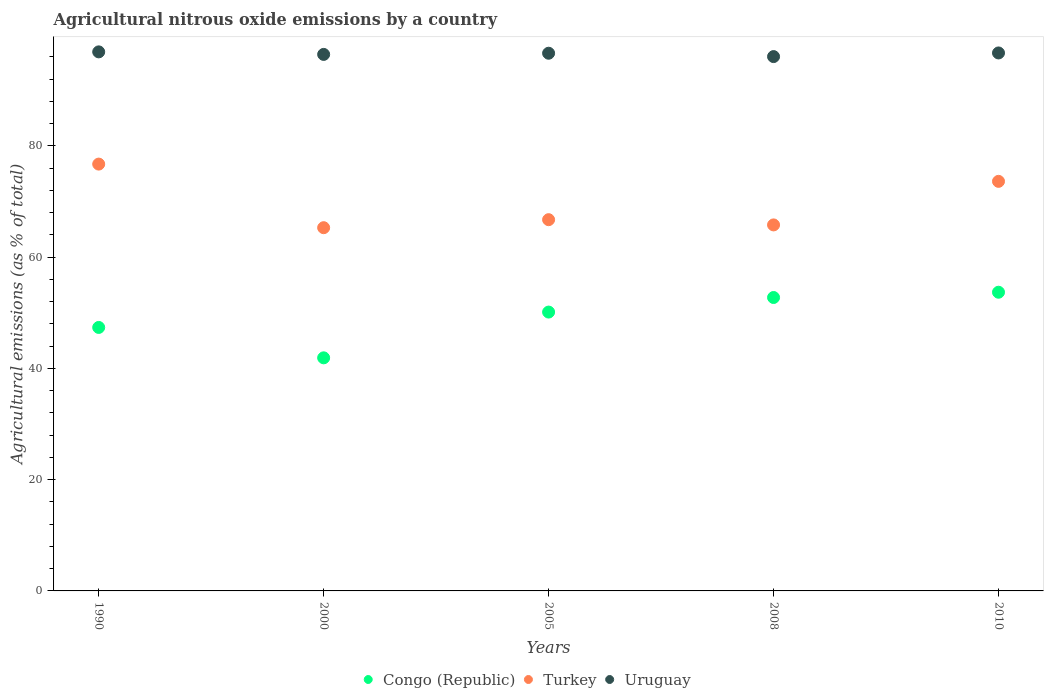How many different coloured dotlines are there?
Make the answer very short. 3. What is the amount of agricultural nitrous oxide emitted in Turkey in 2000?
Your answer should be compact. 65.3. Across all years, what is the maximum amount of agricultural nitrous oxide emitted in Turkey?
Your answer should be very brief. 76.73. Across all years, what is the minimum amount of agricultural nitrous oxide emitted in Turkey?
Your answer should be very brief. 65.3. In which year was the amount of agricultural nitrous oxide emitted in Turkey minimum?
Provide a succinct answer. 2000. What is the total amount of agricultural nitrous oxide emitted in Uruguay in the graph?
Your answer should be compact. 482.79. What is the difference between the amount of agricultural nitrous oxide emitted in Congo (Republic) in 2005 and that in 2010?
Provide a succinct answer. -3.57. What is the difference between the amount of agricultural nitrous oxide emitted in Uruguay in 2000 and the amount of agricultural nitrous oxide emitted in Congo (Republic) in 2005?
Provide a short and direct response. 46.32. What is the average amount of agricultural nitrous oxide emitted in Congo (Republic) per year?
Ensure brevity in your answer.  49.17. In the year 2005, what is the difference between the amount of agricultural nitrous oxide emitted in Uruguay and amount of agricultural nitrous oxide emitted in Turkey?
Your response must be concise. 29.92. In how many years, is the amount of agricultural nitrous oxide emitted in Turkey greater than 52 %?
Offer a terse response. 5. What is the ratio of the amount of agricultural nitrous oxide emitted in Turkey in 2000 to that in 2005?
Your answer should be compact. 0.98. What is the difference between the highest and the second highest amount of agricultural nitrous oxide emitted in Congo (Republic)?
Provide a short and direct response. 0.95. What is the difference between the highest and the lowest amount of agricultural nitrous oxide emitted in Congo (Republic)?
Your response must be concise. 11.79. In how many years, is the amount of agricultural nitrous oxide emitted in Turkey greater than the average amount of agricultural nitrous oxide emitted in Turkey taken over all years?
Your answer should be very brief. 2. Is the sum of the amount of agricultural nitrous oxide emitted in Congo (Republic) in 1990 and 2008 greater than the maximum amount of agricultural nitrous oxide emitted in Turkey across all years?
Give a very brief answer. Yes. Is it the case that in every year, the sum of the amount of agricultural nitrous oxide emitted in Congo (Republic) and amount of agricultural nitrous oxide emitted in Uruguay  is greater than the amount of agricultural nitrous oxide emitted in Turkey?
Ensure brevity in your answer.  Yes. Is the amount of agricultural nitrous oxide emitted in Uruguay strictly less than the amount of agricultural nitrous oxide emitted in Turkey over the years?
Keep it short and to the point. No. How many dotlines are there?
Your answer should be very brief. 3. How many years are there in the graph?
Offer a very short reply. 5. What is the difference between two consecutive major ticks on the Y-axis?
Give a very brief answer. 20. Where does the legend appear in the graph?
Provide a short and direct response. Bottom center. What is the title of the graph?
Give a very brief answer. Agricultural nitrous oxide emissions by a country. What is the label or title of the X-axis?
Provide a succinct answer. Years. What is the label or title of the Y-axis?
Make the answer very short. Agricultural emissions (as % of total). What is the Agricultural emissions (as % of total) of Congo (Republic) in 1990?
Make the answer very short. 47.37. What is the Agricultural emissions (as % of total) in Turkey in 1990?
Ensure brevity in your answer.  76.73. What is the Agricultural emissions (as % of total) in Uruguay in 1990?
Your response must be concise. 96.91. What is the Agricultural emissions (as % of total) in Congo (Republic) in 2000?
Provide a succinct answer. 41.9. What is the Agricultural emissions (as % of total) in Turkey in 2000?
Provide a short and direct response. 65.3. What is the Agricultural emissions (as % of total) of Uruguay in 2000?
Your answer should be compact. 96.45. What is the Agricultural emissions (as % of total) of Congo (Republic) in 2005?
Offer a terse response. 50.13. What is the Agricultural emissions (as % of total) in Turkey in 2005?
Offer a terse response. 66.74. What is the Agricultural emissions (as % of total) of Uruguay in 2005?
Provide a succinct answer. 96.66. What is the Agricultural emissions (as % of total) in Congo (Republic) in 2008?
Your answer should be compact. 52.75. What is the Agricultural emissions (as % of total) in Turkey in 2008?
Provide a succinct answer. 65.8. What is the Agricultural emissions (as % of total) in Uruguay in 2008?
Make the answer very short. 96.06. What is the Agricultural emissions (as % of total) in Congo (Republic) in 2010?
Your answer should be compact. 53.7. What is the Agricultural emissions (as % of total) of Turkey in 2010?
Offer a very short reply. 73.63. What is the Agricultural emissions (as % of total) in Uruguay in 2010?
Your answer should be very brief. 96.71. Across all years, what is the maximum Agricultural emissions (as % of total) in Congo (Republic)?
Provide a succinct answer. 53.7. Across all years, what is the maximum Agricultural emissions (as % of total) in Turkey?
Make the answer very short. 76.73. Across all years, what is the maximum Agricultural emissions (as % of total) in Uruguay?
Make the answer very short. 96.91. Across all years, what is the minimum Agricultural emissions (as % of total) of Congo (Republic)?
Your response must be concise. 41.9. Across all years, what is the minimum Agricultural emissions (as % of total) of Turkey?
Provide a short and direct response. 65.3. Across all years, what is the minimum Agricultural emissions (as % of total) of Uruguay?
Give a very brief answer. 96.06. What is the total Agricultural emissions (as % of total) in Congo (Republic) in the graph?
Your answer should be compact. 245.85. What is the total Agricultural emissions (as % of total) in Turkey in the graph?
Offer a very short reply. 348.2. What is the total Agricultural emissions (as % of total) in Uruguay in the graph?
Your answer should be compact. 482.79. What is the difference between the Agricultural emissions (as % of total) in Congo (Republic) in 1990 and that in 2000?
Offer a terse response. 5.46. What is the difference between the Agricultural emissions (as % of total) of Turkey in 1990 and that in 2000?
Your response must be concise. 11.43. What is the difference between the Agricultural emissions (as % of total) of Uruguay in 1990 and that in 2000?
Give a very brief answer. 0.46. What is the difference between the Agricultural emissions (as % of total) in Congo (Republic) in 1990 and that in 2005?
Provide a succinct answer. -2.76. What is the difference between the Agricultural emissions (as % of total) in Turkey in 1990 and that in 2005?
Make the answer very short. 9.99. What is the difference between the Agricultural emissions (as % of total) of Uruguay in 1990 and that in 2005?
Your answer should be compact. 0.24. What is the difference between the Agricultural emissions (as % of total) in Congo (Republic) in 1990 and that in 2008?
Your answer should be compact. -5.38. What is the difference between the Agricultural emissions (as % of total) in Turkey in 1990 and that in 2008?
Provide a short and direct response. 10.93. What is the difference between the Agricultural emissions (as % of total) of Uruguay in 1990 and that in 2008?
Your response must be concise. 0.85. What is the difference between the Agricultural emissions (as % of total) in Congo (Republic) in 1990 and that in 2010?
Provide a short and direct response. -6.33. What is the difference between the Agricultural emissions (as % of total) in Turkey in 1990 and that in 2010?
Give a very brief answer. 3.1. What is the difference between the Agricultural emissions (as % of total) in Uruguay in 1990 and that in 2010?
Your answer should be very brief. 0.19. What is the difference between the Agricultural emissions (as % of total) in Congo (Republic) in 2000 and that in 2005?
Make the answer very short. -8.23. What is the difference between the Agricultural emissions (as % of total) of Turkey in 2000 and that in 2005?
Provide a short and direct response. -1.44. What is the difference between the Agricultural emissions (as % of total) of Uruguay in 2000 and that in 2005?
Provide a short and direct response. -0.21. What is the difference between the Agricultural emissions (as % of total) of Congo (Republic) in 2000 and that in 2008?
Your answer should be compact. -10.84. What is the difference between the Agricultural emissions (as % of total) in Turkey in 2000 and that in 2008?
Give a very brief answer. -0.5. What is the difference between the Agricultural emissions (as % of total) in Uruguay in 2000 and that in 2008?
Your answer should be compact. 0.39. What is the difference between the Agricultural emissions (as % of total) in Congo (Republic) in 2000 and that in 2010?
Keep it short and to the point. -11.79. What is the difference between the Agricultural emissions (as % of total) in Turkey in 2000 and that in 2010?
Your answer should be compact. -8.33. What is the difference between the Agricultural emissions (as % of total) in Uruguay in 2000 and that in 2010?
Give a very brief answer. -0.26. What is the difference between the Agricultural emissions (as % of total) in Congo (Republic) in 2005 and that in 2008?
Keep it short and to the point. -2.62. What is the difference between the Agricultural emissions (as % of total) in Turkey in 2005 and that in 2008?
Keep it short and to the point. 0.94. What is the difference between the Agricultural emissions (as % of total) of Uruguay in 2005 and that in 2008?
Your answer should be compact. 0.6. What is the difference between the Agricultural emissions (as % of total) in Congo (Republic) in 2005 and that in 2010?
Your answer should be compact. -3.57. What is the difference between the Agricultural emissions (as % of total) in Turkey in 2005 and that in 2010?
Give a very brief answer. -6.89. What is the difference between the Agricultural emissions (as % of total) in Uruguay in 2005 and that in 2010?
Keep it short and to the point. -0.05. What is the difference between the Agricultural emissions (as % of total) in Congo (Republic) in 2008 and that in 2010?
Provide a succinct answer. -0.95. What is the difference between the Agricultural emissions (as % of total) of Turkey in 2008 and that in 2010?
Give a very brief answer. -7.83. What is the difference between the Agricultural emissions (as % of total) in Uruguay in 2008 and that in 2010?
Provide a short and direct response. -0.65. What is the difference between the Agricultural emissions (as % of total) of Congo (Republic) in 1990 and the Agricultural emissions (as % of total) of Turkey in 2000?
Ensure brevity in your answer.  -17.93. What is the difference between the Agricultural emissions (as % of total) of Congo (Republic) in 1990 and the Agricultural emissions (as % of total) of Uruguay in 2000?
Offer a terse response. -49.08. What is the difference between the Agricultural emissions (as % of total) in Turkey in 1990 and the Agricultural emissions (as % of total) in Uruguay in 2000?
Keep it short and to the point. -19.72. What is the difference between the Agricultural emissions (as % of total) of Congo (Republic) in 1990 and the Agricultural emissions (as % of total) of Turkey in 2005?
Give a very brief answer. -19.37. What is the difference between the Agricultural emissions (as % of total) in Congo (Republic) in 1990 and the Agricultural emissions (as % of total) in Uruguay in 2005?
Make the answer very short. -49.3. What is the difference between the Agricultural emissions (as % of total) in Turkey in 1990 and the Agricultural emissions (as % of total) in Uruguay in 2005?
Offer a terse response. -19.93. What is the difference between the Agricultural emissions (as % of total) in Congo (Republic) in 1990 and the Agricultural emissions (as % of total) in Turkey in 2008?
Offer a terse response. -18.43. What is the difference between the Agricultural emissions (as % of total) of Congo (Republic) in 1990 and the Agricultural emissions (as % of total) of Uruguay in 2008?
Give a very brief answer. -48.69. What is the difference between the Agricultural emissions (as % of total) in Turkey in 1990 and the Agricultural emissions (as % of total) in Uruguay in 2008?
Give a very brief answer. -19.33. What is the difference between the Agricultural emissions (as % of total) of Congo (Republic) in 1990 and the Agricultural emissions (as % of total) of Turkey in 2010?
Provide a short and direct response. -26.26. What is the difference between the Agricultural emissions (as % of total) in Congo (Republic) in 1990 and the Agricultural emissions (as % of total) in Uruguay in 2010?
Provide a short and direct response. -49.35. What is the difference between the Agricultural emissions (as % of total) of Turkey in 1990 and the Agricultural emissions (as % of total) of Uruguay in 2010?
Keep it short and to the point. -19.98. What is the difference between the Agricultural emissions (as % of total) in Congo (Republic) in 2000 and the Agricultural emissions (as % of total) in Turkey in 2005?
Provide a short and direct response. -24.84. What is the difference between the Agricultural emissions (as % of total) of Congo (Republic) in 2000 and the Agricultural emissions (as % of total) of Uruguay in 2005?
Your answer should be very brief. -54.76. What is the difference between the Agricultural emissions (as % of total) of Turkey in 2000 and the Agricultural emissions (as % of total) of Uruguay in 2005?
Your answer should be compact. -31.37. What is the difference between the Agricultural emissions (as % of total) of Congo (Republic) in 2000 and the Agricultural emissions (as % of total) of Turkey in 2008?
Keep it short and to the point. -23.9. What is the difference between the Agricultural emissions (as % of total) in Congo (Republic) in 2000 and the Agricultural emissions (as % of total) in Uruguay in 2008?
Provide a succinct answer. -54.15. What is the difference between the Agricultural emissions (as % of total) of Turkey in 2000 and the Agricultural emissions (as % of total) of Uruguay in 2008?
Your response must be concise. -30.76. What is the difference between the Agricultural emissions (as % of total) in Congo (Republic) in 2000 and the Agricultural emissions (as % of total) in Turkey in 2010?
Your answer should be very brief. -31.73. What is the difference between the Agricultural emissions (as % of total) of Congo (Republic) in 2000 and the Agricultural emissions (as % of total) of Uruguay in 2010?
Your answer should be very brief. -54.81. What is the difference between the Agricultural emissions (as % of total) in Turkey in 2000 and the Agricultural emissions (as % of total) in Uruguay in 2010?
Offer a very short reply. -31.42. What is the difference between the Agricultural emissions (as % of total) of Congo (Republic) in 2005 and the Agricultural emissions (as % of total) of Turkey in 2008?
Ensure brevity in your answer.  -15.67. What is the difference between the Agricultural emissions (as % of total) of Congo (Republic) in 2005 and the Agricultural emissions (as % of total) of Uruguay in 2008?
Ensure brevity in your answer.  -45.93. What is the difference between the Agricultural emissions (as % of total) of Turkey in 2005 and the Agricultural emissions (as % of total) of Uruguay in 2008?
Keep it short and to the point. -29.32. What is the difference between the Agricultural emissions (as % of total) of Congo (Republic) in 2005 and the Agricultural emissions (as % of total) of Turkey in 2010?
Your answer should be very brief. -23.5. What is the difference between the Agricultural emissions (as % of total) in Congo (Republic) in 2005 and the Agricultural emissions (as % of total) in Uruguay in 2010?
Your response must be concise. -46.58. What is the difference between the Agricultural emissions (as % of total) of Turkey in 2005 and the Agricultural emissions (as % of total) of Uruguay in 2010?
Your answer should be compact. -29.97. What is the difference between the Agricultural emissions (as % of total) of Congo (Republic) in 2008 and the Agricultural emissions (as % of total) of Turkey in 2010?
Provide a short and direct response. -20.88. What is the difference between the Agricultural emissions (as % of total) in Congo (Republic) in 2008 and the Agricultural emissions (as % of total) in Uruguay in 2010?
Ensure brevity in your answer.  -43.96. What is the difference between the Agricultural emissions (as % of total) of Turkey in 2008 and the Agricultural emissions (as % of total) of Uruguay in 2010?
Your response must be concise. -30.91. What is the average Agricultural emissions (as % of total) of Congo (Republic) per year?
Keep it short and to the point. 49.17. What is the average Agricultural emissions (as % of total) in Turkey per year?
Provide a succinct answer. 69.64. What is the average Agricultural emissions (as % of total) in Uruguay per year?
Your answer should be very brief. 96.56. In the year 1990, what is the difference between the Agricultural emissions (as % of total) of Congo (Republic) and Agricultural emissions (as % of total) of Turkey?
Ensure brevity in your answer.  -29.36. In the year 1990, what is the difference between the Agricultural emissions (as % of total) in Congo (Republic) and Agricultural emissions (as % of total) in Uruguay?
Provide a succinct answer. -49.54. In the year 1990, what is the difference between the Agricultural emissions (as % of total) of Turkey and Agricultural emissions (as % of total) of Uruguay?
Provide a succinct answer. -20.17. In the year 2000, what is the difference between the Agricultural emissions (as % of total) in Congo (Republic) and Agricultural emissions (as % of total) in Turkey?
Provide a succinct answer. -23.39. In the year 2000, what is the difference between the Agricultural emissions (as % of total) in Congo (Republic) and Agricultural emissions (as % of total) in Uruguay?
Provide a succinct answer. -54.55. In the year 2000, what is the difference between the Agricultural emissions (as % of total) of Turkey and Agricultural emissions (as % of total) of Uruguay?
Offer a very short reply. -31.15. In the year 2005, what is the difference between the Agricultural emissions (as % of total) of Congo (Republic) and Agricultural emissions (as % of total) of Turkey?
Offer a terse response. -16.61. In the year 2005, what is the difference between the Agricultural emissions (as % of total) of Congo (Republic) and Agricultural emissions (as % of total) of Uruguay?
Give a very brief answer. -46.53. In the year 2005, what is the difference between the Agricultural emissions (as % of total) of Turkey and Agricultural emissions (as % of total) of Uruguay?
Offer a very short reply. -29.92. In the year 2008, what is the difference between the Agricultural emissions (as % of total) of Congo (Republic) and Agricultural emissions (as % of total) of Turkey?
Make the answer very short. -13.05. In the year 2008, what is the difference between the Agricultural emissions (as % of total) in Congo (Republic) and Agricultural emissions (as % of total) in Uruguay?
Provide a short and direct response. -43.31. In the year 2008, what is the difference between the Agricultural emissions (as % of total) in Turkey and Agricultural emissions (as % of total) in Uruguay?
Keep it short and to the point. -30.26. In the year 2010, what is the difference between the Agricultural emissions (as % of total) of Congo (Republic) and Agricultural emissions (as % of total) of Turkey?
Ensure brevity in your answer.  -19.93. In the year 2010, what is the difference between the Agricultural emissions (as % of total) of Congo (Republic) and Agricultural emissions (as % of total) of Uruguay?
Your response must be concise. -43.02. In the year 2010, what is the difference between the Agricultural emissions (as % of total) in Turkey and Agricultural emissions (as % of total) in Uruguay?
Give a very brief answer. -23.08. What is the ratio of the Agricultural emissions (as % of total) of Congo (Republic) in 1990 to that in 2000?
Give a very brief answer. 1.13. What is the ratio of the Agricultural emissions (as % of total) in Turkey in 1990 to that in 2000?
Your answer should be compact. 1.18. What is the ratio of the Agricultural emissions (as % of total) in Congo (Republic) in 1990 to that in 2005?
Your answer should be compact. 0.94. What is the ratio of the Agricultural emissions (as % of total) of Turkey in 1990 to that in 2005?
Your answer should be compact. 1.15. What is the ratio of the Agricultural emissions (as % of total) of Congo (Republic) in 1990 to that in 2008?
Provide a short and direct response. 0.9. What is the ratio of the Agricultural emissions (as % of total) in Turkey in 1990 to that in 2008?
Offer a very short reply. 1.17. What is the ratio of the Agricultural emissions (as % of total) in Uruguay in 1990 to that in 2008?
Make the answer very short. 1.01. What is the ratio of the Agricultural emissions (as % of total) in Congo (Republic) in 1990 to that in 2010?
Offer a terse response. 0.88. What is the ratio of the Agricultural emissions (as % of total) in Turkey in 1990 to that in 2010?
Make the answer very short. 1.04. What is the ratio of the Agricultural emissions (as % of total) of Uruguay in 1990 to that in 2010?
Offer a very short reply. 1. What is the ratio of the Agricultural emissions (as % of total) in Congo (Republic) in 2000 to that in 2005?
Provide a succinct answer. 0.84. What is the ratio of the Agricultural emissions (as % of total) in Turkey in 2000 to that in 2005?
Provide a short and direct response. 0.98. What is the ratio of the Agricultural emissions (as % of total) in Uruguay in 2000 to that in 2005?
Offer a very short reply. 1. What is the ratio of the Agricultural emissions (as % of total) in Congo (Republic) in 2000 to that in 2008?
Your answer should be compact. 0.79. What is the ratio of the Agricultural emissions (as % of total) of Turkey in 2000 to that in 2008?
Offer a very short reply. 0.99. What is the ratio of the Agricultural emissions (as % of total) in Uruguay in 2000 to that in 2008?
Make the answer very short. 1. What is the ratio of the Agricultural emissions (as % of total) in Congo (Republic) in 2000 to that in 2010?
Your response must be concise. 0.78. What is the ratio of the Agricultural emissions (as % of total) of Turkey in 2000 to that in 2010?
Offer a very short reply. 0.89. What is the ratio of the Agricultural emissions (as % of total) in Uruguay in 2000 to that in 2010?
Provide a short and direct response. 1. What is the ratio of the Agricultural emissions (as % of total) in Congo (Republic) in 2005 to that in 2008?
Ensure brevity in your answer.  0.95. What is the ratio of the Agricultural emissions (as % of total) of Turkey in 2005 to that in 2008?
Keep it short and to the point. 1.01. What is the ratio of the Agricultural emissions (as % of total) of Congo (Republic) in 2005 to that in 2010?
Ensure brevity in your answer.  0.93. What is the ratio of the Agricultural emissions (as % of total) of Turkey in 2005 to that in 2010?
Give a very brief answer. 0.91. What is the ratio of the Agricultural emissions (as % of total) in Uruguay in 2005 to that in 2010?
Keep it short and to the point. 1. What is the ratio of the Agricultural emissions (as % of total) of Congo (Republic) in 2008 to that in 2010?
Offer a very short reply. 0.98. What is the ratio of the Agricultural emissions (as % of total) of Turkey in 2008 to that in 2010?
Your answer should be very brief. 0.89. What is the ratio of the Agricultural emissions (as % of total) in Uruguay in 2008 to that in 2010?
Keep it short and to the point. 0.99. What is the difference between the highest and the second highest Agricultural emissions (as % of total) in Congo (Republic)?
Ensure brevity in your answer.  0.95. What is the difference between the highest and the second highest Agricultural emissions (as % of total) of Turkey?
Your answer should be very brief. 3.1. What is the difference between the highest and the second highest Agricultural emissions (as % of total) of Uruguay?
Ensure brevity in your answer.  0.19. What is the difference between the highest and the lowest Agricultural emissions (as % of total) of Congo (Republic)?
Offer a terse response. 11.79. What is the difference between the highest and the lowest Agricultural emissions (as % of total) in Turkey?
Offer a very short reply. 11.43. What is the difference between the highest and the lowest Agricultural emissions (as % of total) in Uruguay?
Your response must be concise. 0.85. 